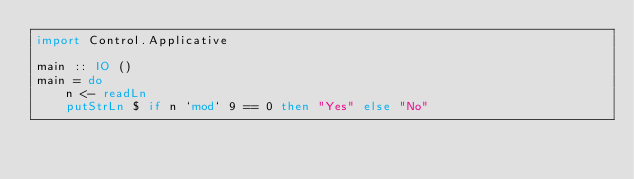Convert code to text. <code><loc_0><loc_0><loc_500><loc_500><_Haskell_>import Control.Applicative

main :: IO ()
main = do
    n <- readLn
    putStrLn $ if n `mod` 9 == 0 then "Yes" else "No"</code> 